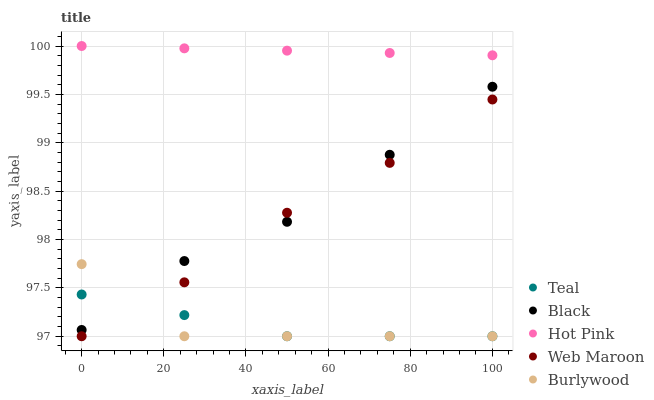Does Burlywood have the minimum area under the curve?
Answer yes or no. Yes. Does Hot Pink have the maximum area under the curve?
Answer yes or no. Yes. Does Web Maroon have the minimum area under the curve?
Answer yes or no. No. Does Web Maroon have the maximum area under the curve?
Answer yes or no. No. Is Hot Pink the smoothest?
Answer yes or no. Yes. Is Burlywood the roughest?
Answer yes or no. Yes. Is Web Maroon the smoothest?
Answer yes or no. No. Is Web Maroon the roughest?
Answer yes or no. No. Does Burlywood have the lowest value?
Answer yes or no. Yes. Does Hot Pink have the lowest value?
Answer yes or no. No. Does Hot Pink have the highest value?
Answer yes or no. Yes. Does Web Maroon have the highest value?
Answer yes or no. No. Is Teal less than Hot Pink?
Answer yes or no. Yes. Is Hot Pink greater than Burlywood?
Answer yes or no. Yes. Does Black intersect Burlywood?
Answer yes or no. Yes. Is Black less than Burlywood?
Answer yes or no. No. Is Black greater than Burlywood?
Answer yes or no. No. Does Teal intersect Hot Pink?
Answer yes or no. No. 